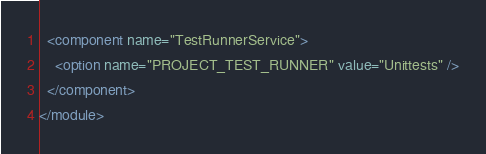Convert code to text. <code><loc_0><loc_0><loc_500><loc_500><_XML_>  <component name="TestRunnerService">
    <option name="PROJECT_TEST_RUNNER" value="Unittests" />
  </component>
</module></code> 